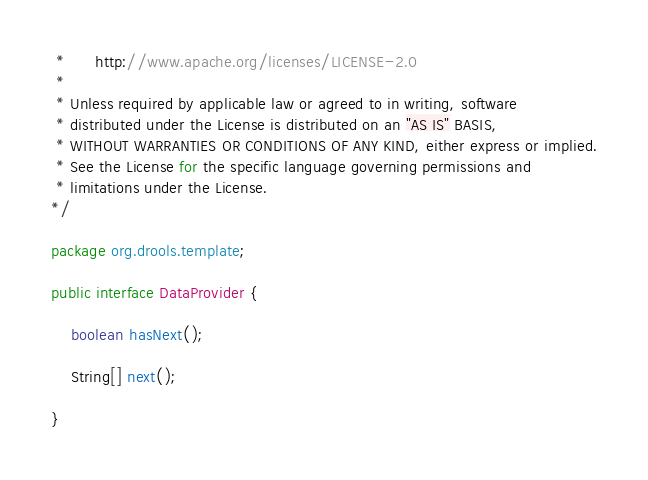Convert code to text. <code><loc_0><loc_0><loc_500><loc_500><_Java_> *      http://www.apache.org/licenses/LICENSE-2.0
 *
 * Unless required by applicable law or agreed to in writing, software
 * distributed under the License is distributed on an "AS IS" BASIS,
 * WITHOUT WARRANTIES OR CONDITIONS OF ANY KIND, either express or implied.
 * See the License for the specific language governing permissions and
 * limitations under the License.
*/

package org.drools.template;

public interface DataProvider {

    boolean hasNext();

    String[] next();

}
</code> 